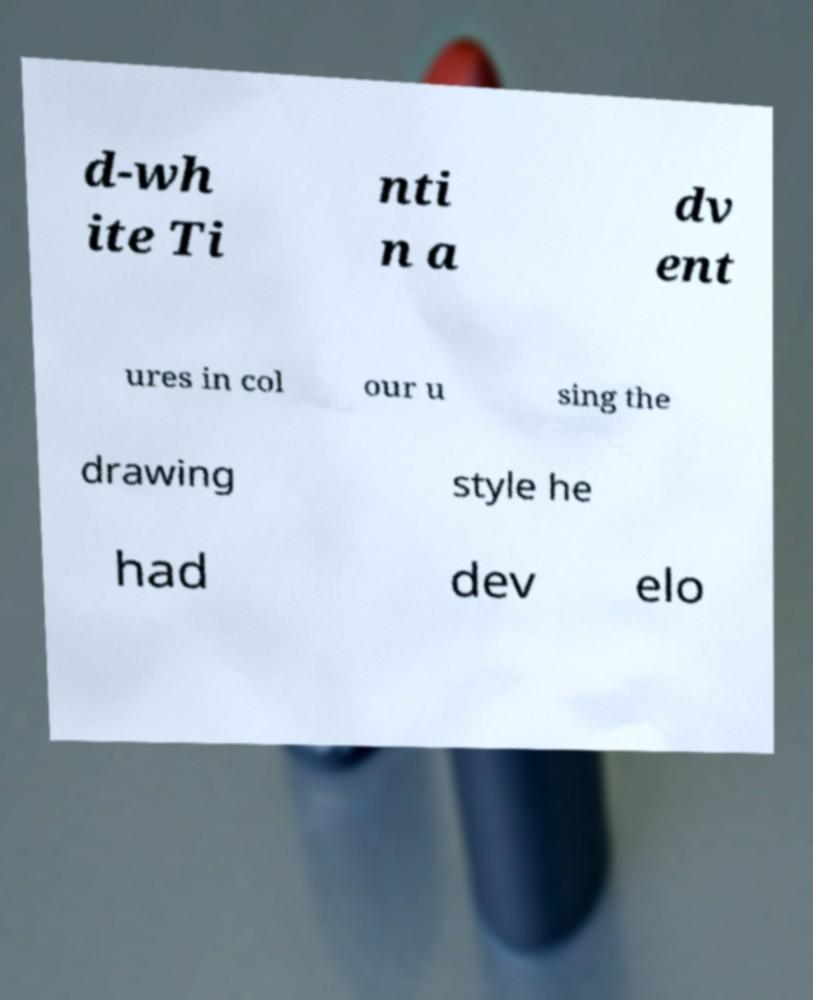Please identify and transcribe the text found in this image. d-wh ite Ti nti n a dv ent ures in col our u sing the drawing style he had dev elo 